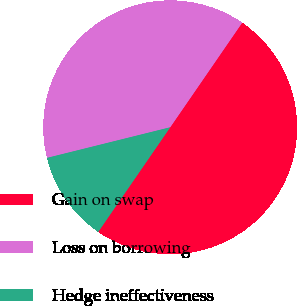Convert chart. <chart><loc_0><loc_0><loc_500><loc_500><pie_chart><fcel>Gain on swap<fcel>Loss on borrowing<fcel>Hedge ineffectiveness<nl><fcel>50.0%<fcel>38.47%<fcel>11.53%<nl></chart> 